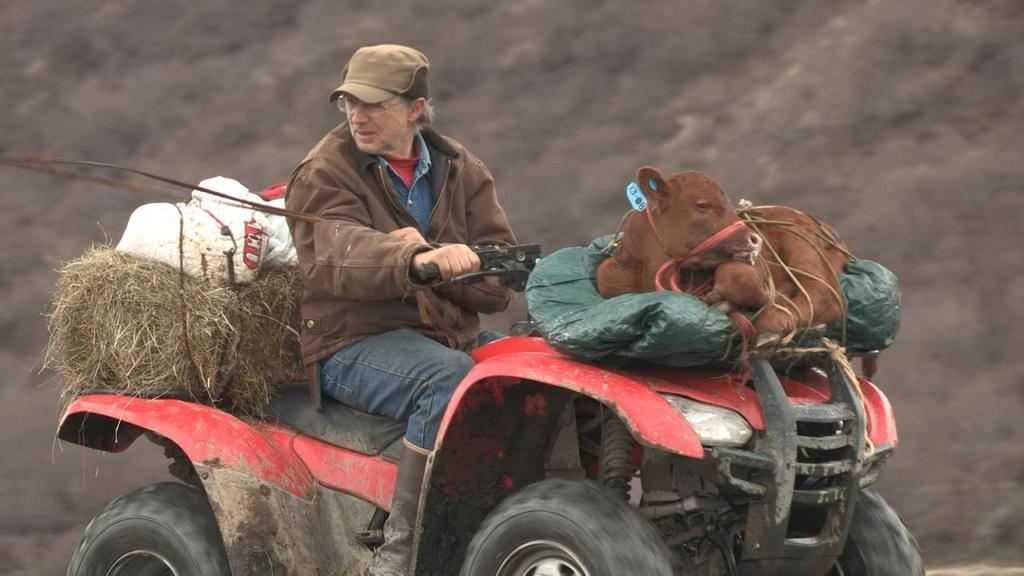What type of vehicle is in the image? There is a vehicle in the image, but the specific type is not mentioned. Where is the vehicle located? The vehicle is on the ground in the image. Who is present in the image besides the vehicle? There is a man and an animal in the image. What is the terrain like in the image? There is grass in the image, suggesting a grassy or outdoor setting. What is on the vehicle? There are objects on the vehicle. Reasoning: Let' Let's think step by step in order to produce the conversation. We start by identifying the main subject in the image, which is the vehicle. Then, we expand the conversation to include other items that are also visible, such as the man, the animal, the grass, and the objects on the vehicle. Each question is designed to elicit a specific detail about the image that is known from the provided facts. Absurd Question/Answer: What type of books can be seen in the library in the image? There is no library present in the image, so it is not possible to answer that question. 